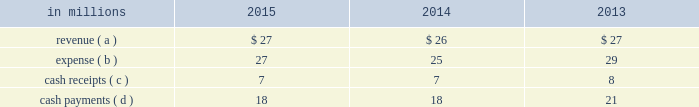( c ) the cash payments are interest payments on the associated debt obligations discussed above .
After formation of the 2015 financing entities , the payments represent interest paid on nonrecourse financial liabilities of special purpose entities .
In connection with the acquisition of temple-inland in february 2012 , two special purpose entities became wholly-owned subsidiaries of international paper .
The use of the two wholly-owned special purpose entities discussed below preserved the tax deferral that resulted from the 2007 temple-inland timberlands sales .
The company recognized an $ 840 million deferred tax liability in connection with the 2007 sales , which will be settled with the maturity of the notes in in october 2007 , temple-inland sold 1.55 million acres of timberland for $ 2.38 billion .
The total consideration consisted almost entirely of notes due in 2027 issued by the buyer of the timberland , which temple-inland contributed to two wholly-owned , bankruptcy-remote special purpose entities .
The notes are shown in financial assets of special purpose entities in the accompanying consolidated balance sheet and are supported by $ 2.38 billion of irrevocable letters of credit issued by three banks , which are required to maintain minimum credit ratings on their long-term debt .
In the third quarter of 2012 , international paper completed its preliminary analysis of the acquisition date fair value of the notes and determined it to be $ 2.09 billion .
As of december 31 , 2015 and 2014 , the fair value of the notes was $ 2.10 billion and $ 2.27 billion , respectively .
These notes are classified as level 2 within the fair value hierarchy , which is further defined in note 14 .
In december 2007 , temple-inland's two wholly-owned special purpose entities borrowed $ 2.14 billion shown in nonrecourse financial liabilities of special purpose entities .
The loans are repayable in 2027 and are secured only by the $ 2.38 billion of notes and the irrevocable letters of credit securing the notes and are nonrecourse to us .
The loan agreements provide that if a credit rating of any of the banks issuing the letters of credit is downgraded below the specified threshold , the letters of credit issued by that bank must be replaced within 30 days with letters of credit from another qualifying financial institution .
In the third quarter of 2012 , international paper completed its preliminary analysis of the acquisition date fair value of the borrowings and determined it to be $ 2.03 billion .
As of december 31 , 2015 and 2014 , the fair value of this debt was $ 1.97 billion and $ 2.16 billion , respectively .
This debt is classified as level 2 within the fair value hierarchy , which is further defined in note 14 .
Activity between the company and the 2007 financing entities was as follows: .
( a ) the revenue is included in interest expense , net in the accompanying consolidated statement of operations and includes approximately $ 19 million , $ 19 million and $ 19 million for the years ended december 31 , 2015 , 2014 and 2013 , respectively , of accretion income for the amortization of the purchase accounting adjustment on the financial assets of special purpose entities .
( b ) the expense is included in interest expense , net in the accompanying consolidated statement of operations and includes approximately $ 7 million , $ 7 million and $ 7 million for the years ended december 31 , 2015 , 2014 and 2013 , respectively , of accretion expense for the amortization of the purchase accounting adjustment on the nonrecourse financial liabilities of special purpose entities .
( c ) the cash receipts are interest received on the financial assets of special purpose entities .
( d ) the cash payments are interest paid on nonrecourse financial liabilities of special purpose entities .
Note 13 debt and lines of credit in 2015 , international paper issued $ 700 million of 3.80% ( 3.80 % ) senior unsecured notes with a maturity date in 2026 , $ 600 million of 5.00% ( 5.00 % ) senior unsecured notes with a maturity date in 2035 , and $ 700 million of 5.15% ( 5.15 % ) senior unsecured notes with a maturity date in 2046 .
The proceeds from this borrowing were used to repay approximately $ 1.0 billion of notes with interest rates ranging from 4.75% ( 4.75 % ) to 9.38% ( 9.38 % ) and original maturities from 2018 to 2022 , along with $ 211 million of cash premiums associated with the debt repayments .
Additionally , the proceeds from this borrowing were used to make a $ 750 million voluntary cash contribution to the company's pension plan .
Pre-tax early debt retirement costs of $ 207 million related to the debt repayments , including the $ 211 million of cash premiums , are included in restructuring and other charges in the accompanying consolidated statement of operations for the twelve months ended december 31 , 2015 .
During the second quarter of 2014 , international paper issued $ 800 million of 3.65% ( 3.65 % ) senior unsecured notes with a maturity date in 2024 and $ 800 million of 4.80% ( 4.80 % ) senior unsecured notes with a maturity date in 2044 .
The proceeds from this borrowing were used to repay approximately $ 960 million of notes with interest rates ranging from 7.95% ( 7.95 % ) to 9.38% ( 9.38 % ) and original maturities from 2018 to 2019 .
Pre-tax early debt retirement costs of $ 262 million related to these debt repayments , including $ 258 million of cash premiums , are included in restructuring and other charges in the accompanying consolidated statement of operations for the twelve months ended december 31 , 2014. .
What was the ratio of the fair value of international paper completed preliminary analysis of the acquisition date fair value of the borrowings in 2015 compared to 2014? 
Computations: (1.97 / 2.16)
Answer: 0.91204. 